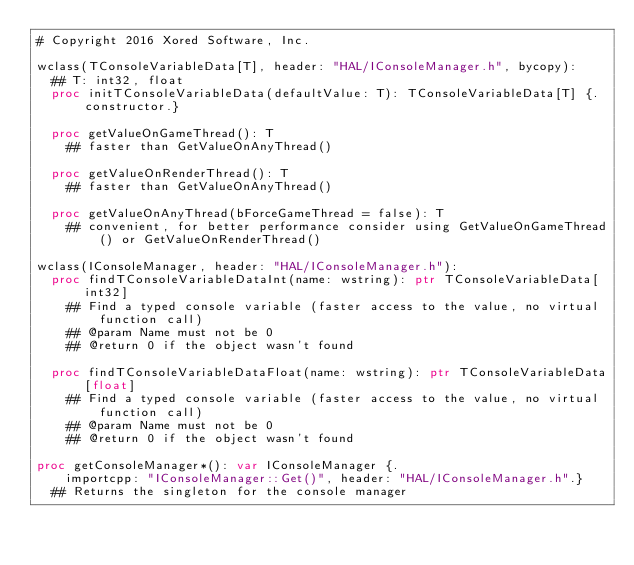Convert code to text. <code><loc_0><loc_0><loc_500><loc_500><_Nim_># Copyright 2016 Xored Software, Inc.

wclass(TConsoleVariableData[T], header: "HAL/IConsoleManager.h", bycopy):
  ## T: int32, float
  proc initTConsoleVariableData(defaultValue: T): TConsoleVariableData[T] {.constructor.}

  proc getValueOnGameThread(): T
    ## faster than GetValueOnAnyThread()

  proc getValueOnRenderThread(): T
    ## faster than GetValueOnAnyThread()

  proc getValueOnAnyThread(bForceGameThread = false): T
    ## convenient, for better performance consider using GetValueOnGameThread() or GetValueOnRenderThread()

wclass(IConsoleManager, header: "HAL/IConsoleManager.h"):
  proc findTConsoleVariableDataInt(name: wstring): ptr TConsoleVariableData[int32]
    ## Find a typed console variable (faster access to the value, no virtual function call)
    ## @param Name must not be 0
    ## @return 0 if the object wasn't found

  proc findTConsoleVariableDataFloat(name: wstring): ptr TConsoleVariableData[float]
    ## Find a typed console variable (faster access to the value, no virtual function call)
    ## @param Name must not be 0
    ## @return 0 if the object wasn't found

proc getConsoleManager*(): var IConsoleManager {.
    importcpp: "IConsoleManager::Get()", header: "HAL/IConsoleManager.h".}
  ## Returns the singleton for the console manager
</code> 